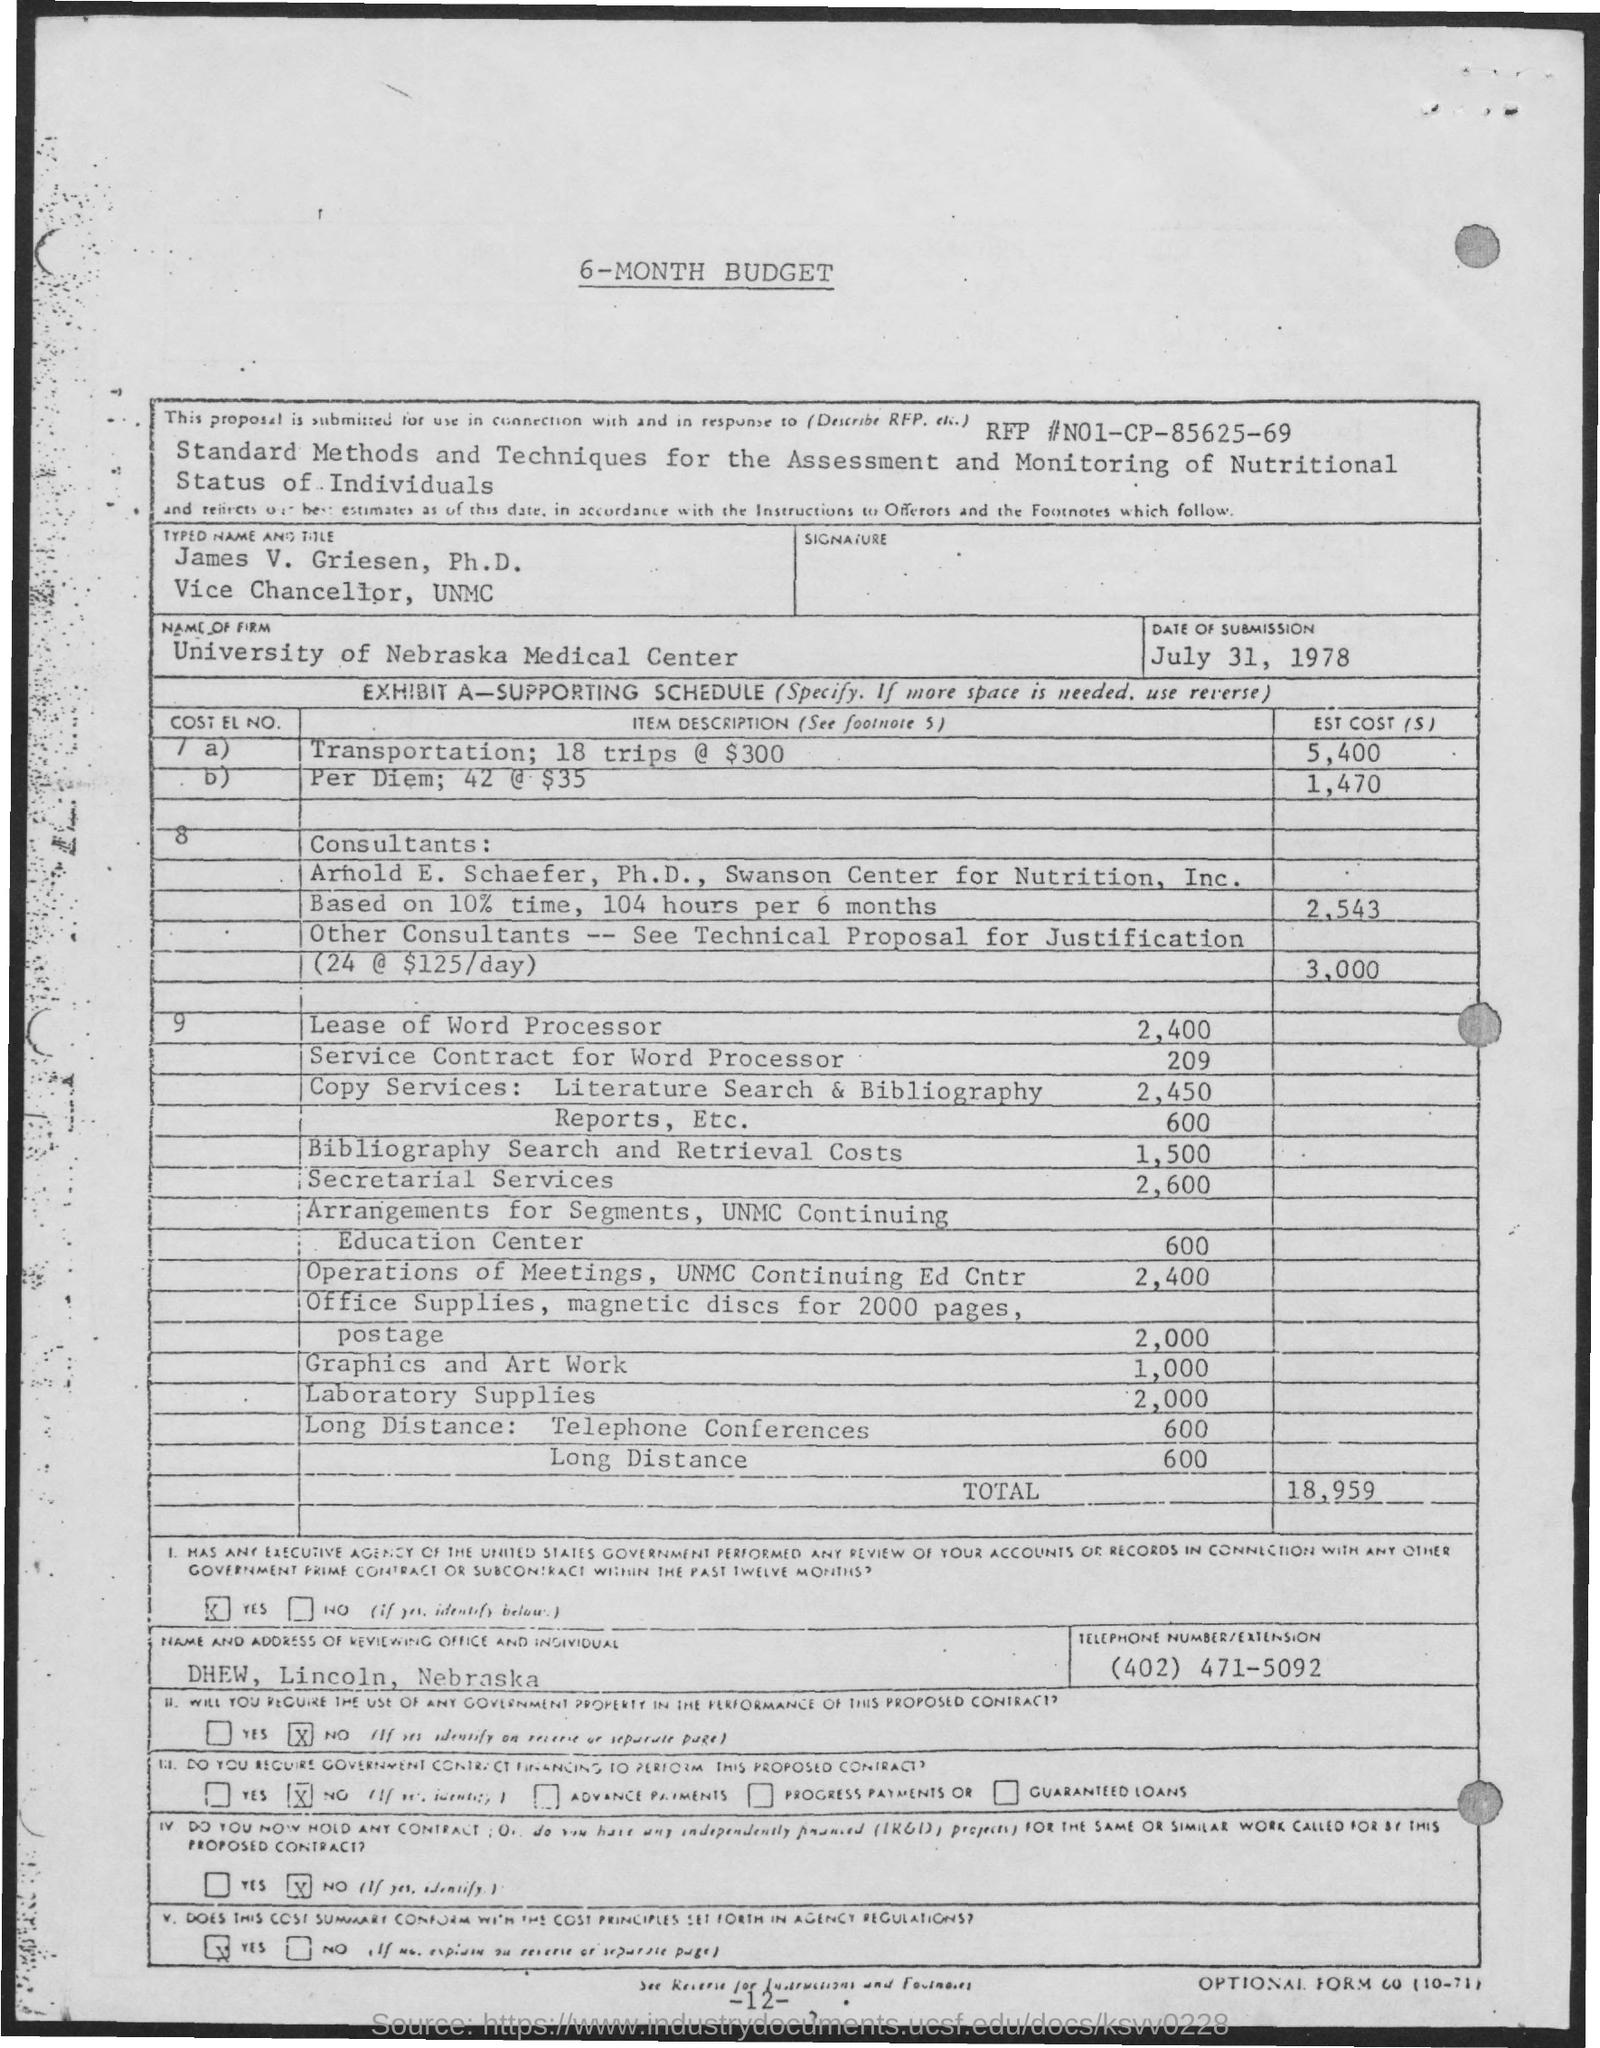What is the RFP# mentioned in the form?
Your answer should be compact. N01-CP-85625-69. What is the name given in the form?
Your answer should be very brief. JAMES V. GRIESEN. What is the job title of James V. Griesen, Ph.D.?
Your answer should be very brief. Vice chancellor. What is the date of submission mentioned in the form?
Give a very brief answer. July 31, 1978. What is the name of the firm mentioned in the form?
Offer a terse response. UNIVERSITY OF NEBRASKA MEDICAL CENTER. What is the total estimated budget given?
Your response must be concise. 18,959. What is the Telephone No mentioned in this form?
Keep it short and to the point. (402) 471-5092. What is the estimated cost of laboratory supplies?
Make the answer very short. 2,000. How much is the estimated cost for secretarial services?
Give a very brief answer. 2,600. 